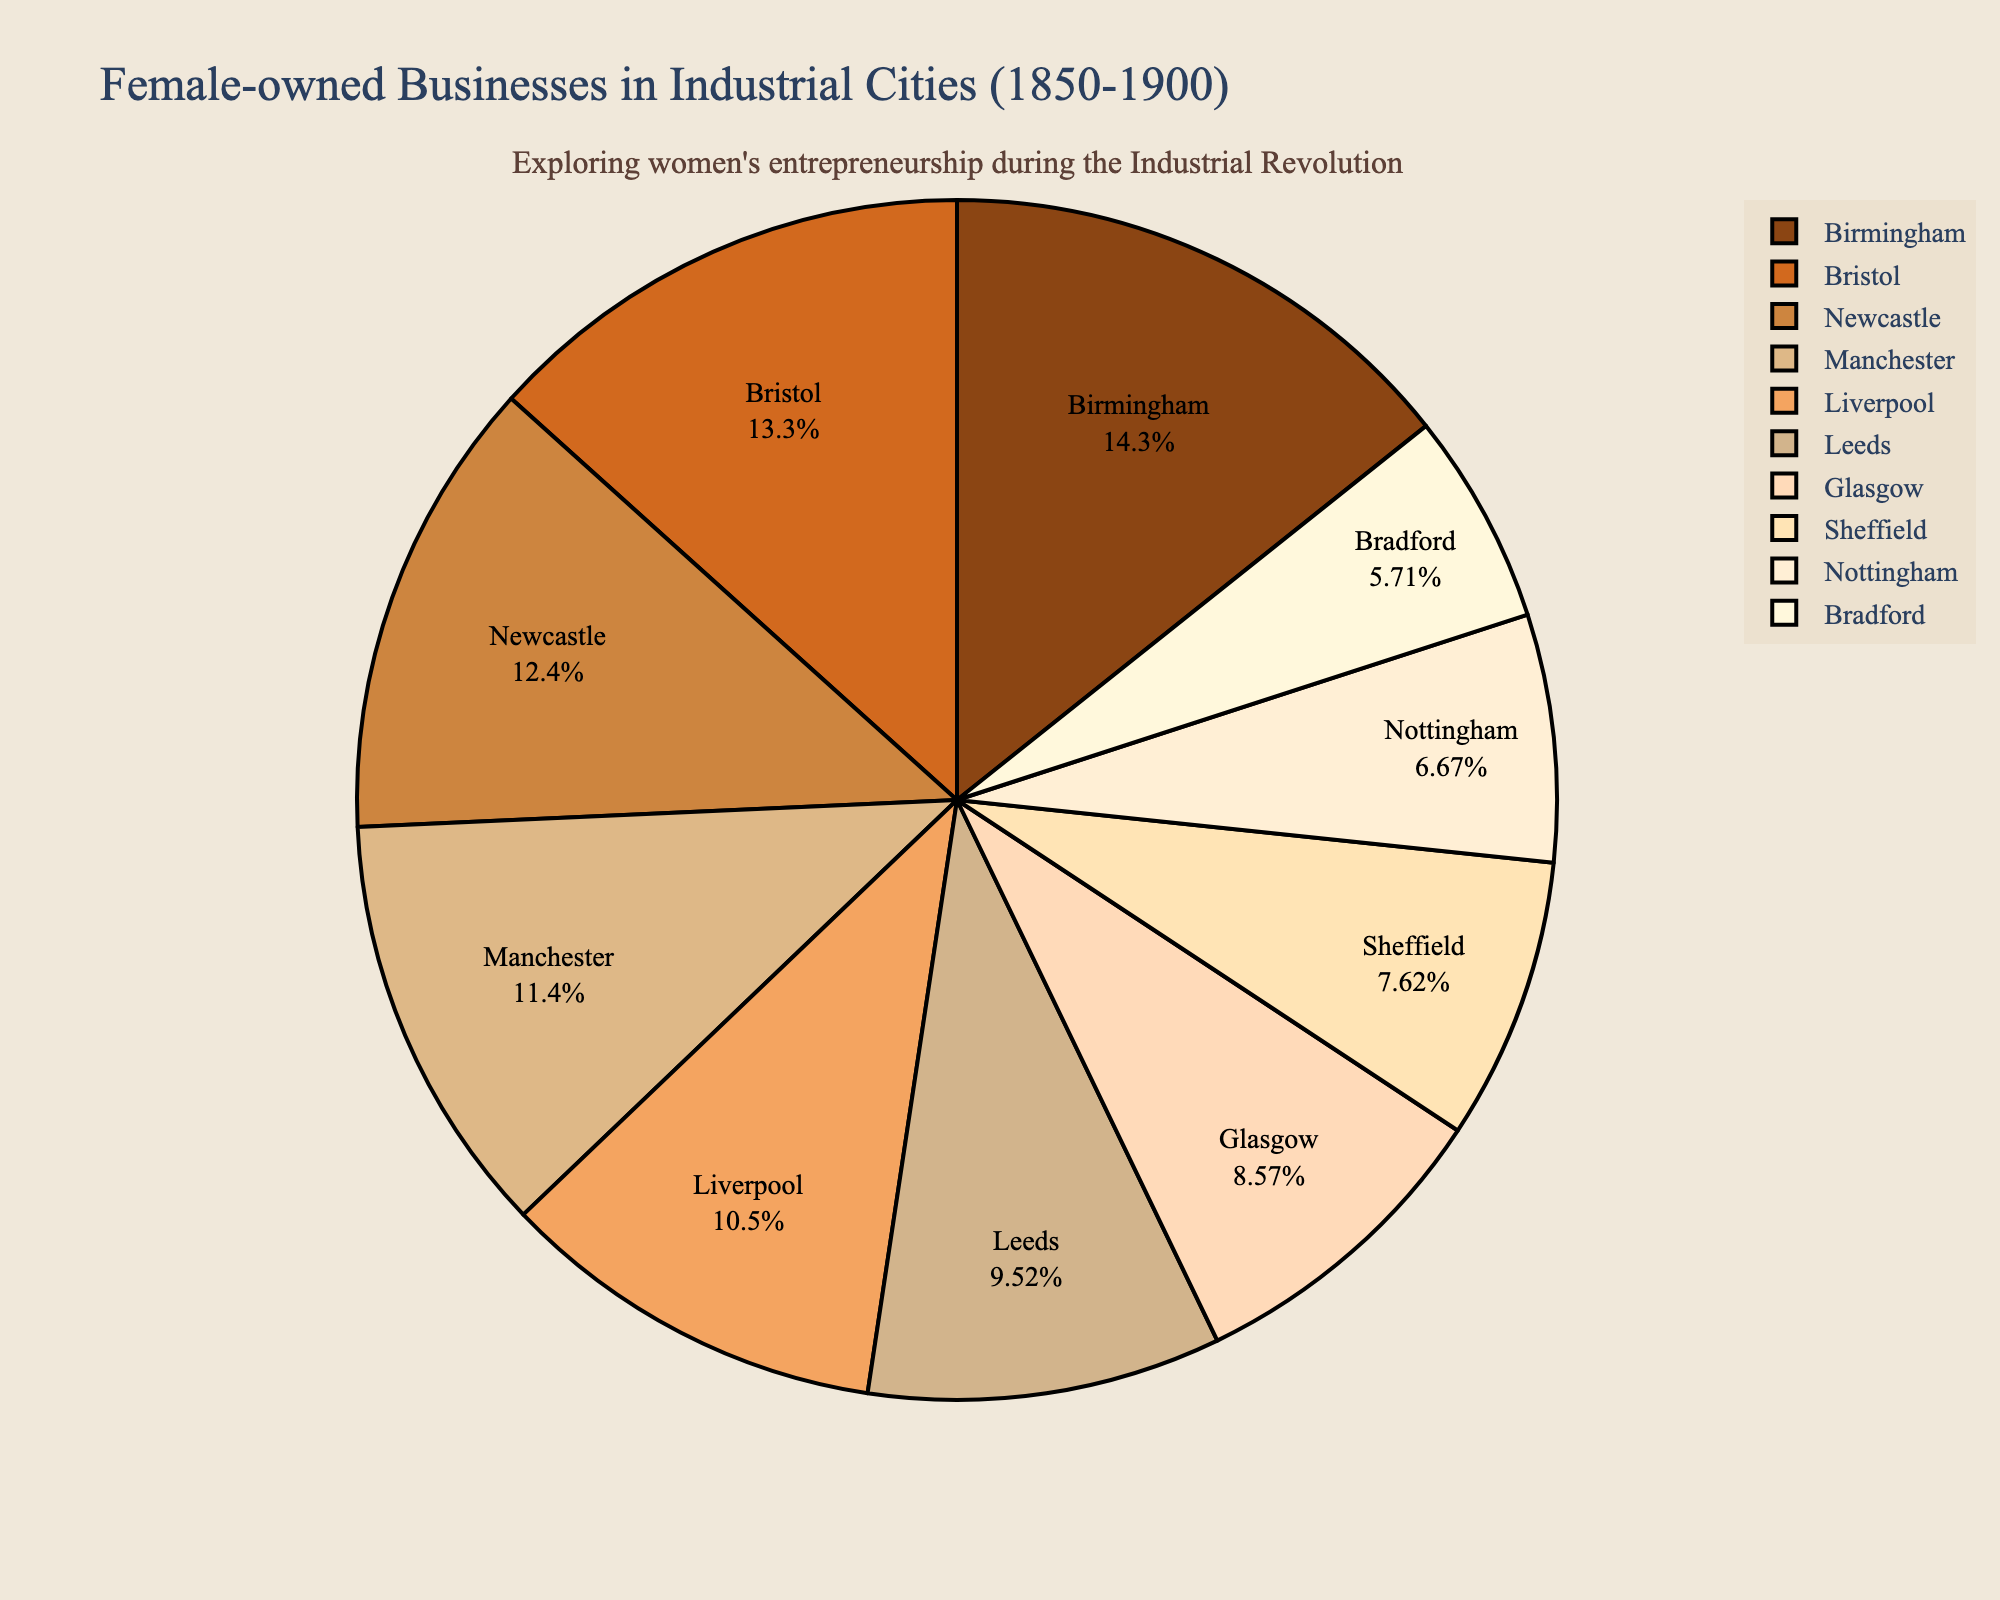what percentage of female-owned businesses are in Manchester and Birmingham combined? Manchester has 12% and Birmingham has 15%. Adding these together, 12% + 15% = 27%
Answer: 27% which city has a higher percentage of female-owned businesses, Leeds or Newcastle? Leeds has 10% while Newcastle has 13%. Therefore, Newcastle has a higher percentage.
Answer: Newcastle what is the smallest percentage of female-owned businesses and which city does it belong to? The smallest percentage shown is 6%, which belongs to Bradford.
Answer: Bradford what percentage of female-owned businesses are in the top three cities? The top three cities are Birmingham (15%), Bristol (14%), and Newcastle (13%). Adding these together, 15% + 14% + 13% = 42%
Answer: 42% how does the percentage of female-owned businesses in Sheffield compare to Liverpool? Sheffield has 8% while Liverpool has 11%. Comparing the two, Liverpool has a higher percentage.
Answer: Liverpool combine the percentages of female-owned businesses in Nottingham, Bradford, and Glasgow. What is the total percentage? Nottingham has 7%, Bradford has 6%, and Glasgow has 9%. Adding these together, 7% + 6% + 9% = 22%
Answer: 22% which cities have a percentage of female-owned businesses greater than the average percentage of all cities? First, calculate the average percentage. Adding all percentages and dividing by the number of cities, (12 + 15 + 10 + 9 + 11 + 8 + 13 + 14 + 7 + 6) / 10 = 9.5%. The cities with percentages greater than 9.5% are Manchester, Birmingham, Leeds, Liverpool, Newcastle, and Bristol.
Answer: Manchester, Birmingham, Leeds, Liverpool, Newcastle, Bristol 